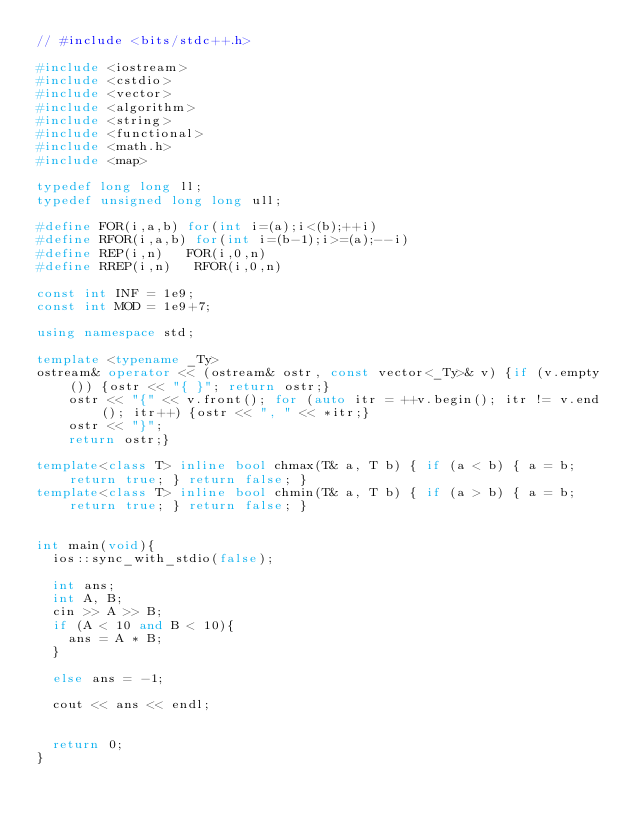Convert code to text. <code><loc_0><loc_0><loc_500><loc_500><_C++_>// #include <bits/stdc++.h>

#include <iostream>
#include <cstdio>
#include <vector>
#include <algorithm>
#include <string>
#include <functional>
#include <math.h>
#include <map>

typedef long long ll;
typedef unsigned long long ull;

#define FOR(i,a,b) for(int i=(a);i<(b);++i)
#define RFOR(i,a,b) for(int i=(b-1);i>=(a);--i)
#define REP(i,n)   FOR(i,0,n)
#define RREP(i,n)   RFOR(i,0,n)

const int INF = 1e9;
const int MOD = 1e9+7;

using namespace std;

template <typename _Ty>
ostream& operator << (ostream& ostr, const vector<_Ty>& v) {if (v.empty()) {ostr << "{ }"; return ostr;}
    ostr << "{" << v.front(); for (auto itr = ++v.begin(); itr != v.end(); itr++) {ostr << ", " << *itr;}
    ostr << "}";
    return ostr;}

template<class T> inline bool chmax(T& a, T b) { if (a < b) { a = b; return true; } return false; }
template<class T> inline bool chmin(T& a, T b) { if (a > b) { a = b; return true; } return false; }


int main(void){
  ios::sync_with_stdio(false);

  int ans;
  int A, B;
  cin >> A >> B;
  if (A < 10 and B < 10){
    ans = A * B;
  }

  else ans = -1;

  cout << ans << endl;


  return 0;
}

</code> 